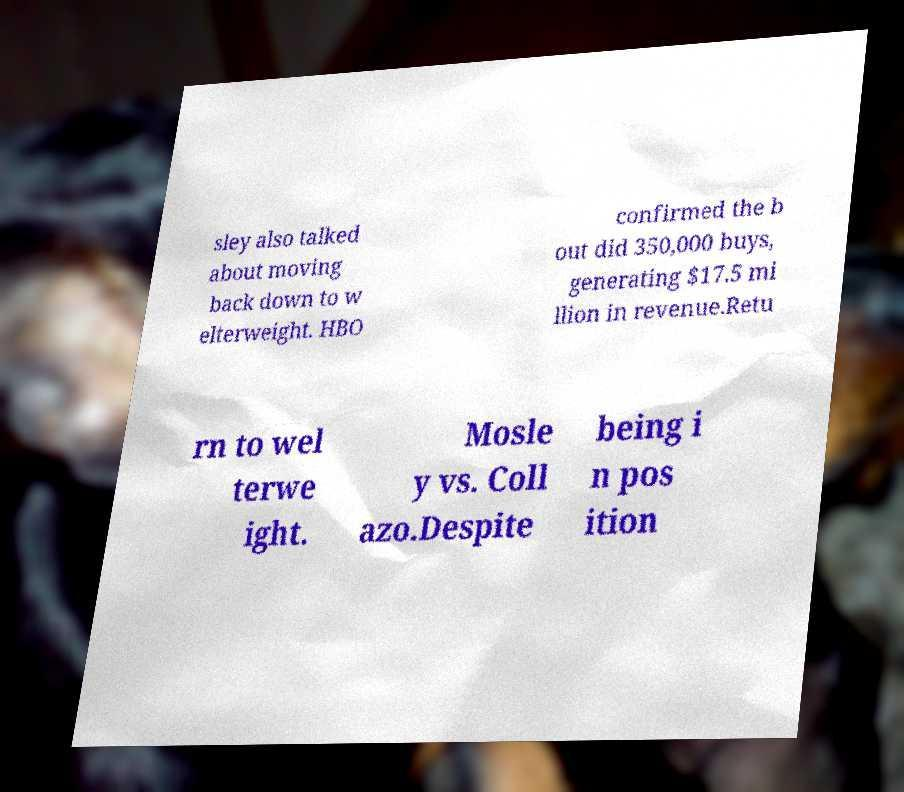Please read and relay the text visible in this image. What does it say? sley also talked about moving back down to w elterweight. HBO confirmed the b out did 350,000 buys, generating $17.5 mi llion in revenue.Retu rn to wel terwe ight. Mosle y vs. Coll azo.Despite being i n pos ition 